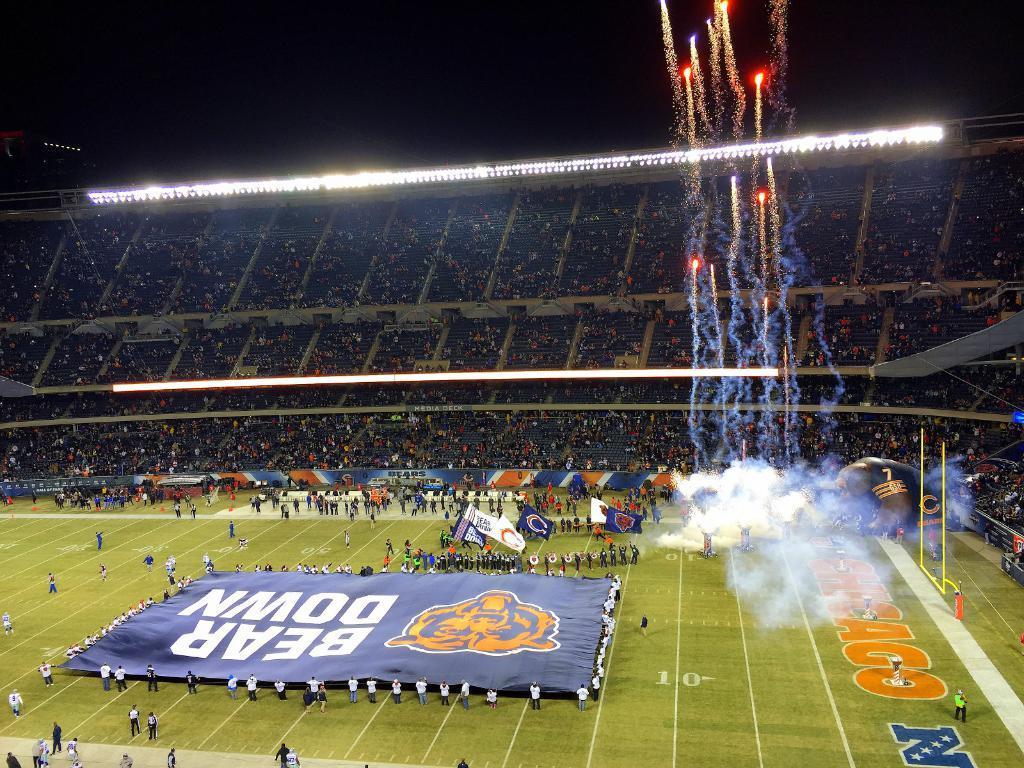How would you summarize this image in a sentence or two? In this picture we can see a stadium, at the bottom there is grass, we can see some people in the middle, some of them are holding flags, there are lights in the background, we can see smoke on the right side, we can also see hoardings and some people in the background. 